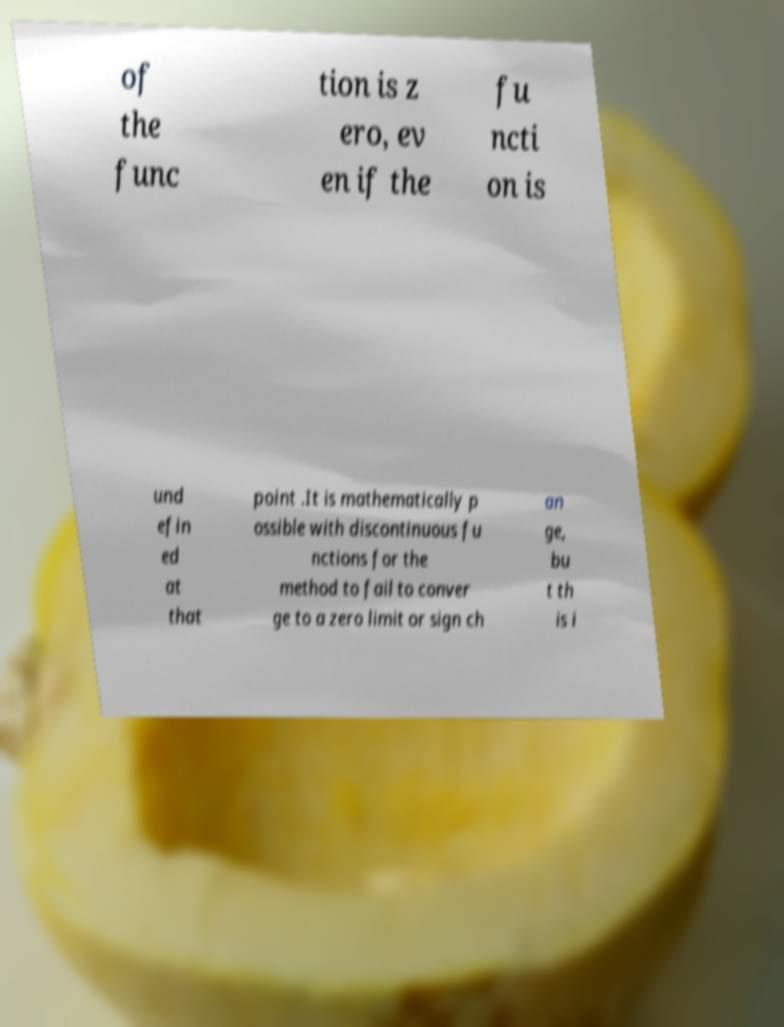I need the written content from this picture converted into text. Can you do that? of the func tion is z ero, ev en if the fu ncti on is und efin ed at that point .It is mathematically p ossible with discontinuous fu nctions for the method to fail to conver ge to a zero limit or sign ch an ge, bu t th is i 